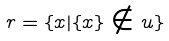Convert formula to latex. <formula><loc_0><loc_0><loc_500><loc_500>r = \{ x | \{ x \} \notin u \}</formula> 